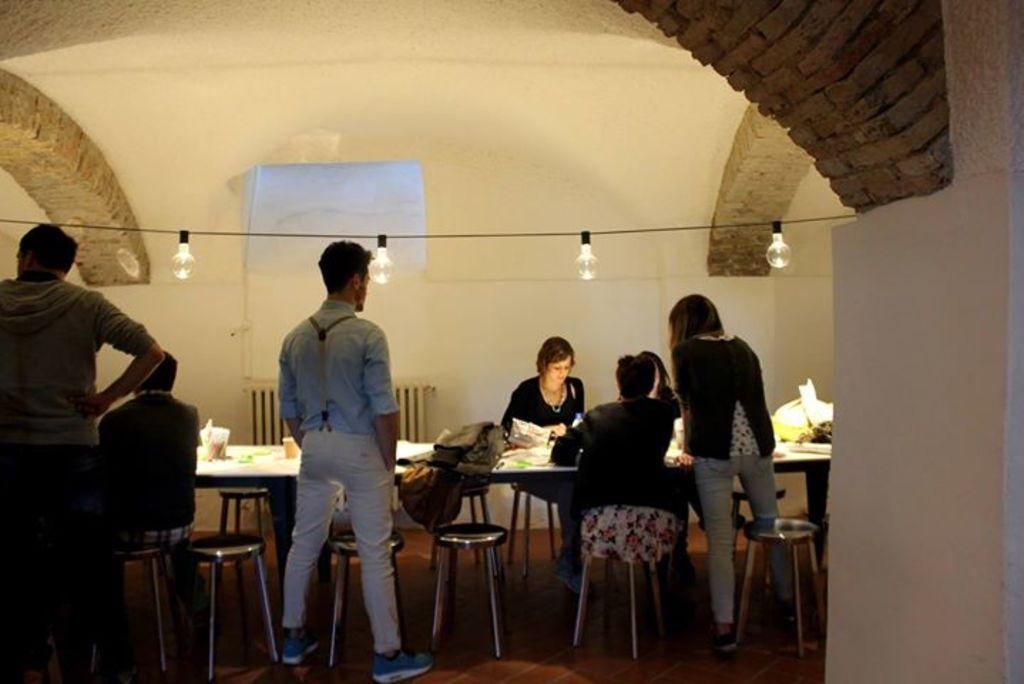What are the people in the image doing? There are persons standing and sitting on chairs in the image. Can you describe any objects visible in the image? There is a bag visible in the image, as well as cups and other objects on the table. What is the source of illumination in the image? There are lights visible at the top of the image. What can be seen in the background of the image? There is a wall in the background of the image. What type of goose is sitting on the table in the image? There is no goose present in the image; the objects on the table are unrelated to a goose. What type of work are the people in the image engaged in? The image does not provide any information about the work or occupation of the people; they are simply standing or sitting. 